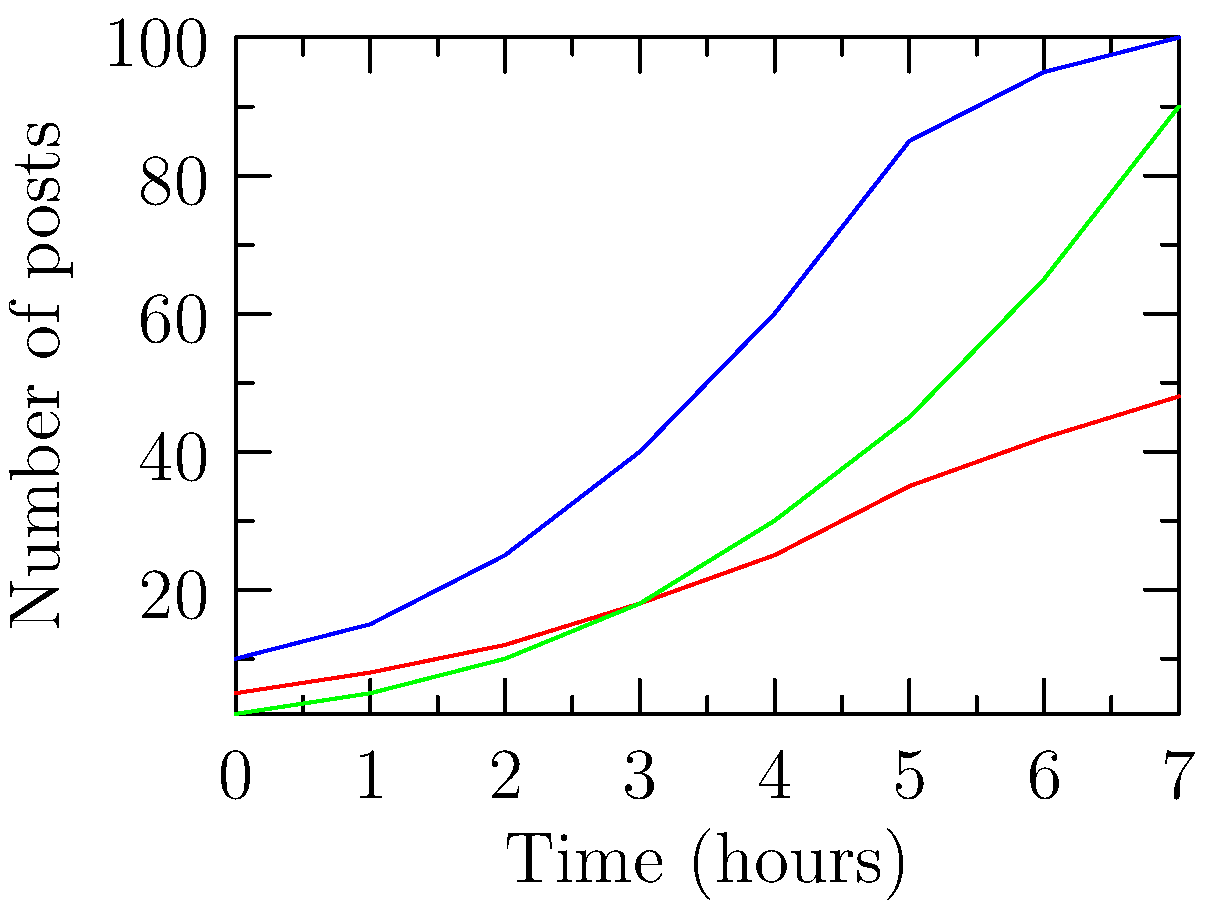Based on the line graph showing the growth of three hashtags over 7 hours, which hashtag is most likely to become the top trending topic in the next hour? To predict which hashtag is most likely to become the top trending topic in the next hour, we need to analyze the growth patterns of each hashtag:

1. #TrendyTech (blue line):
   - Started with the highest initial posts
   - Shows steady growth but is flattening towards the end
   - Current value: 100 posts

2. #SocialCause (red line):
   - Started with moderate initial posts
   - Shows consistent but slow growth
   - Current value: 48 posts

3. #ViralChallenge (green line):
   - Started with the lowest initial posts
   - Shows exponential growth, especially in the last 3 hours
   - Current value: 90 posts

To predict the next hour's trend, we need to consider the current momentum and growth rate:

1. Calculate the growth rate for the last hour:
   #TrendyTech: (100 - 95) / 95 ≈ 5.3%
   #SocialCause: (48 - 42) / 42 ≈ 14.3%
   #ViralChallenge: (90 - 65) / 65 ≈ 38.5%

2. Estimate the next hour's values:
   #TrendyTech: 100 * (1 + 0.053) ≈ 105
   #SocialCause: 48 * (1 + 0.143) ≈ 55
   #ViralChallenge: 90 * (1 + 0.385) ≈ 125

Based on these calculations, #ViralChallenge is most likely to become the top trending topic in the next hour due to its exponential growth rate and projected value.
Answer: #ViralChallenge 